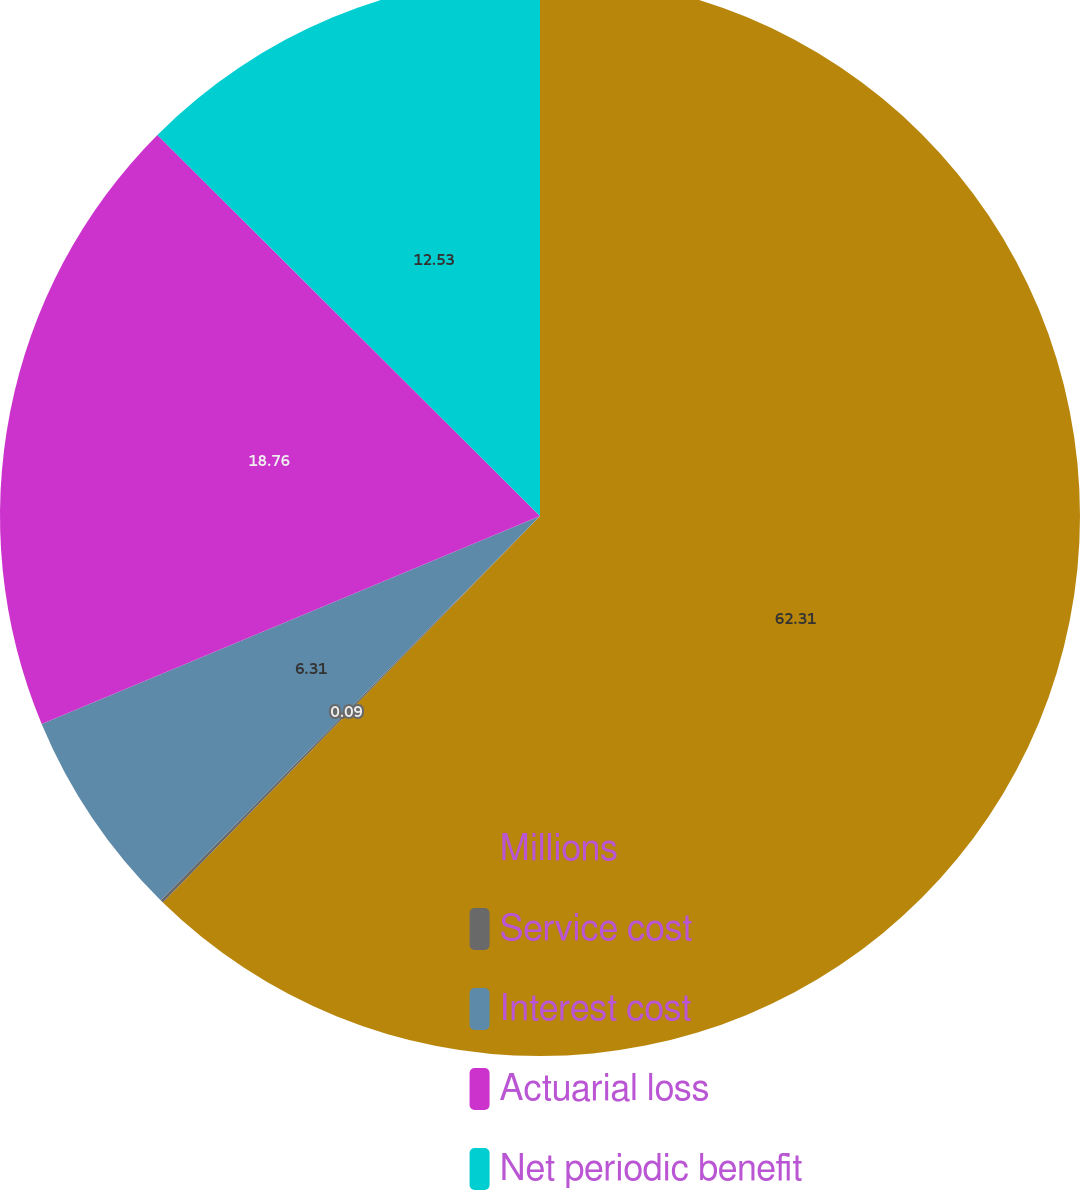<chart> <loc_0><loc_0><loc_500><loc_500><pie_chart><fcel>Millions<fcel>Service cost<fcel>Interest cost<fcel>Actuarial loss<fcel>Net periodic benefit<nl><fcel>62.3%<fcel>0.09%<fcel>6.31%<fcel>18.76%<fcel>12.53%<nl></chart> 